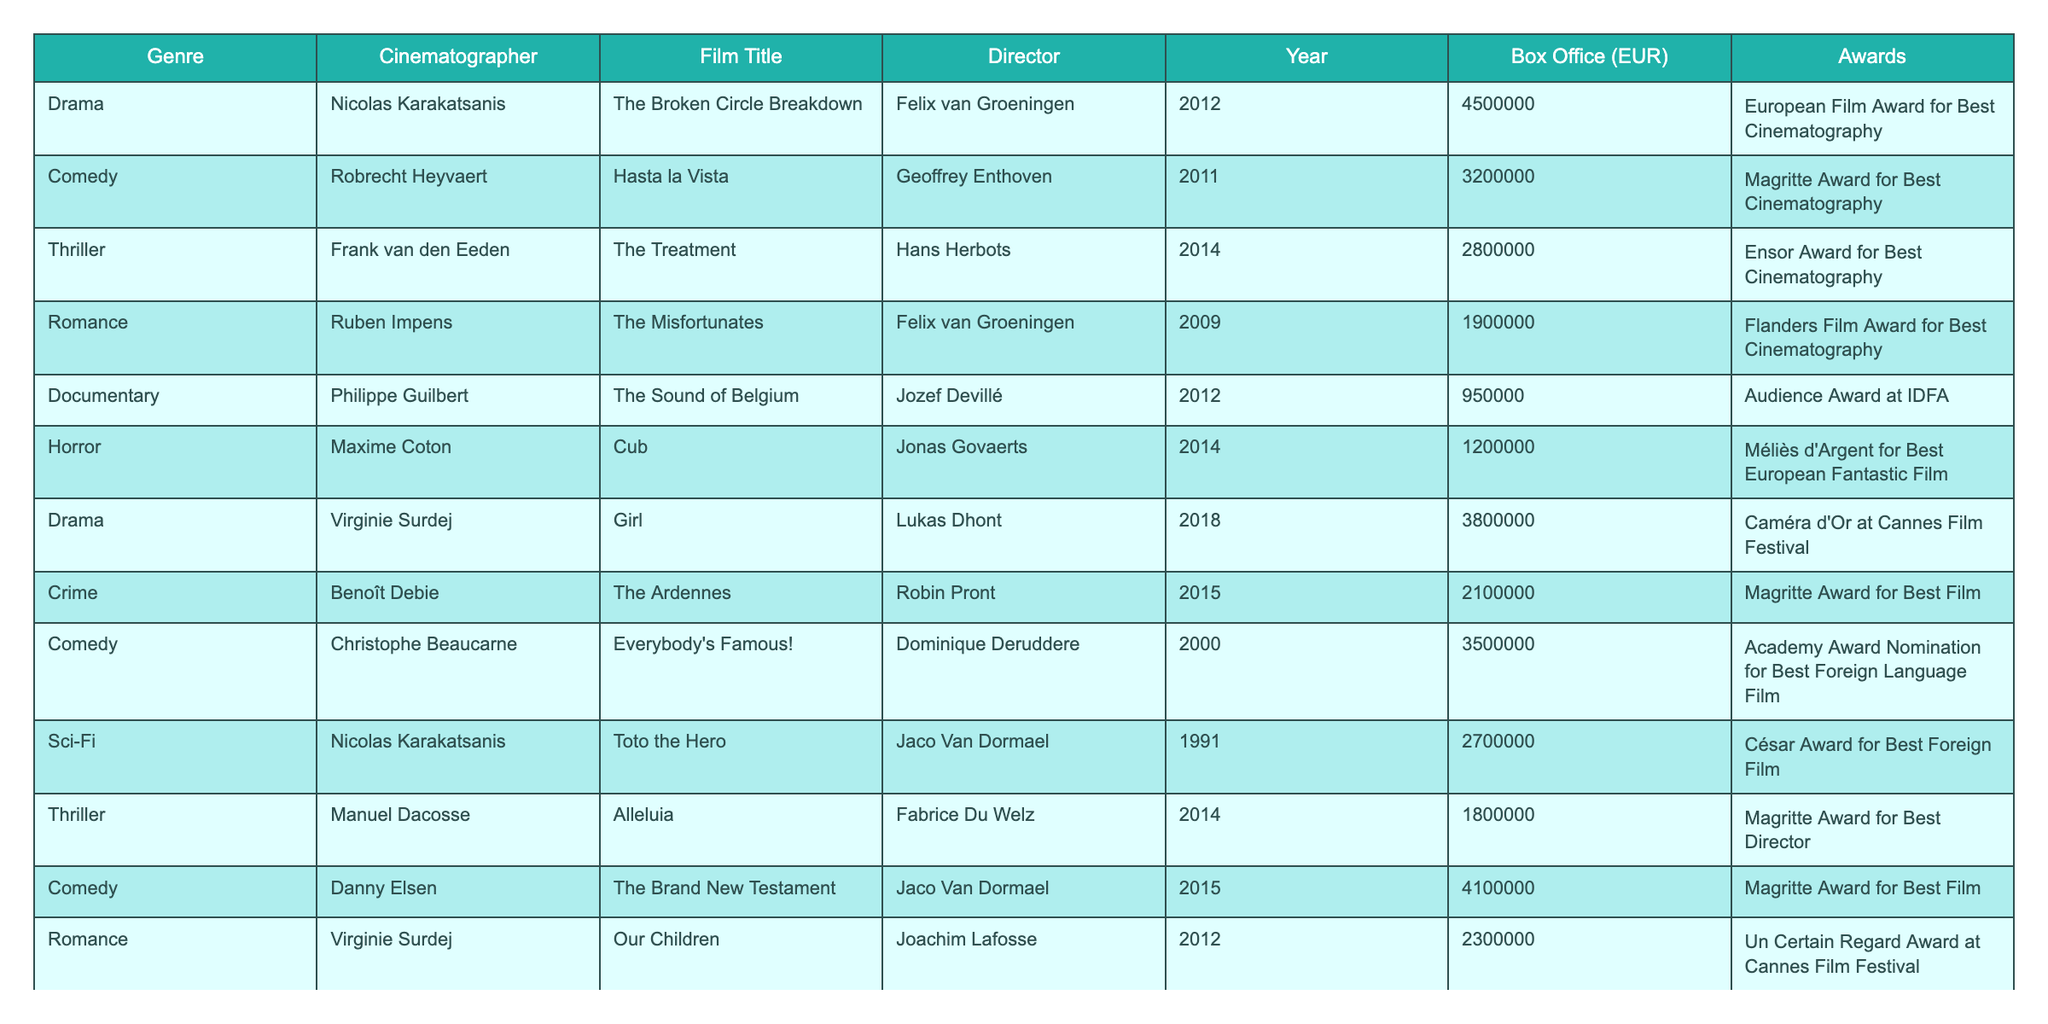What is the box office performance of "The Broken Circle Breakdown"? The box office performance for "The Broken Circle Breakdown," directed by Felix van Groeningen and shot by Nicolas Karakatsanis in 2012, is listed as 4,500,000 EUR in the table.
Answer: 4,500,000 EUR Which film had the highest box office among comedies listed? In the table, the comedic films include "Hasta la Vista" with 3,200,000 EUR, "Everybody's Famous!" with 3,500,000 EUR, and "The Brand New Testament" with 4,100,000 EUR. The highest among them is "The Brand New Testament" at 4,100,000 EUR.
Answer: "The Brand New Testament" (4,100,000 EUR) Is there a documentary film in the table with awards? The table shows that there is a documentary titled "No Man's Land," which has received the Best Documentary award at the Ghent Film Festival, confirming that there is indeed a documentary with awards in the list.
Answer: Yes What is the average box office for films shot by Virginie Surdej? Virginie Surdej worked on two films: "Girl" with a box office of 3,800,000 EUR and "Our Children" with 2,300,000 EUR. To find the average, we sum these: 3,800,000 + 2,300,000 = 6,100,000 EUR, then divide by 2 to get 6,100,000 / 2 = 3,050,000 EUR.
Answer: 3,050,000 EUR Which genre has the lowest overall box office performance based on the table? By reviewing the box office figures for each genre: Drama (8,800,000 EUR), Comedy (7,600,000 EUR), Thriller (4,460,000 EUR), Romance (4,200,000 EUR), Documentary (1,730,000 EUR), and Horror (1,200,000 EUR), we find that Horror has the lowest total at 1,200,000 EUR.
Answer: Horror Which cinematographer collaborates the most with directors in the table? Each cinematographer's films can be counted: Nicolas Karakatsanis: 2 films, Robrecht Heyvaert: 1 film, Frank van den Eeden: 1 film, Ruben Impens: 1 film, Philippe Guilbert: 1 film, Maxime Coton: 1 film, Virginie Surdej: 2 films, Benoît Debie: 1 film, Christophe Beaucarne: 1 film, Danny Elsen: 1 film, and Manuel Dacosse: 1 film. Nicolas Karakatsanis and Virginie Surdej each have directed 2 films, but since the question focuses on collaboration with the highest number of films, we should consider both as co-collaborators.
Answer: Nicolas Karakatsanis and Virginie Surdej What percentage of box office is attributed to drama films? The total box office from the table is: 4,500,000 + 3,200,000 + 2,800,000 + 1,900,000 + 950,000 + 1,200,000 + 3,800,000 + 2,100,000 + 3,500,000 + 2,700,000 + 1,800,000 + 4,100,000 + 2,300,000 + 780,000 = 38,290,000 EUR. The total for drama films is 4,500,000 + 3,800,000 = 8,300,000 EUR. Thus the percentage is (8,300,000 / 38,290,000) * 100 ≈ 21.65%.
Answer: Approximately 21.65% How many films are there with box office earnings above 3 million EUR? The table indicates films above this threshold are: "The Broken Circle Breakdown" (4,500,000 EUR), "Everybody's Famous!" (3,500,000 EUR), "The Brand New Testament" (4,100,000 EUR), "Girl" (3,800,000 EUR), and "Hasta la Vista" (3,200,000 EUR). This gives us a total of 5 films.
Answer: 5 